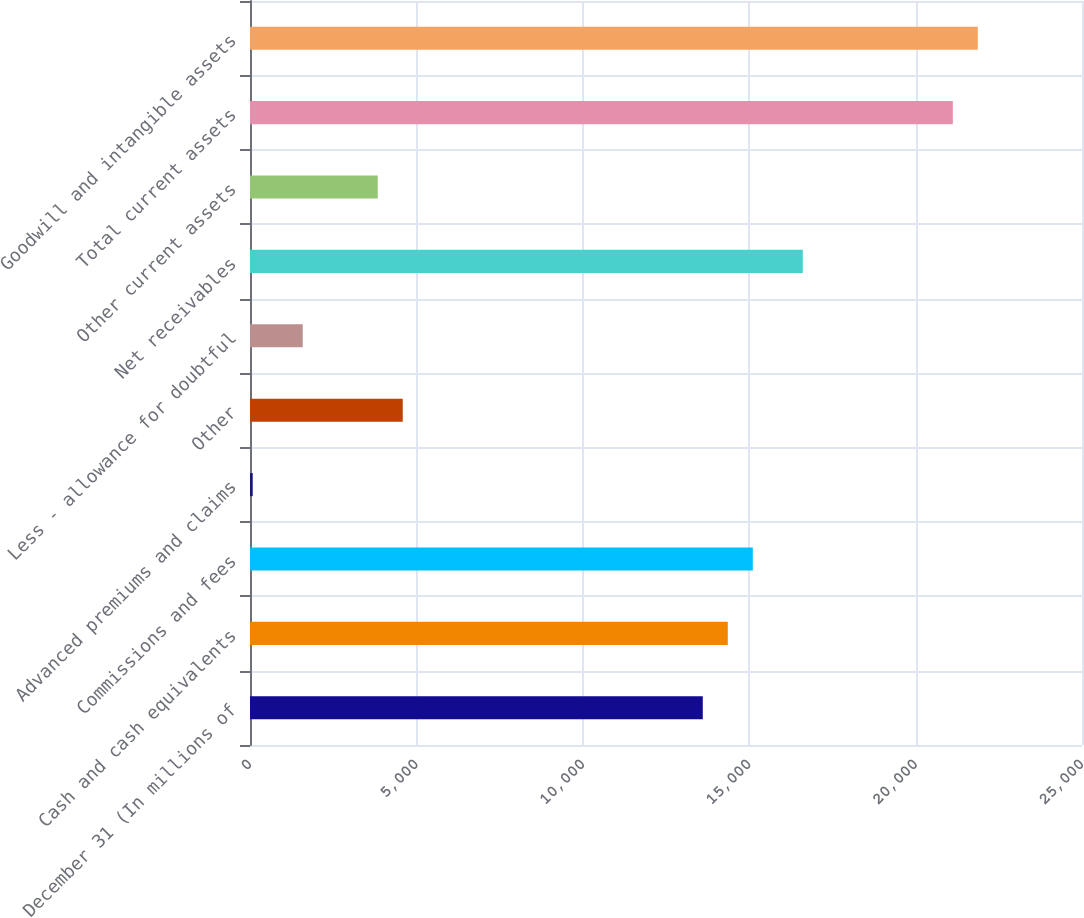Convert chart. <chart><loc_0><loc_0><loc_500><loc_500><bar_chart><fcel>December 31 (In millions of<fcel>Cash and cash equivalents<fcel>Commissions and fees<fcel>Advanced premiums and claims<fcel>Other<fcel>Less - allowance for doubtful<fcel>Net receivables<fcel>Other current assets<fcel>Total current assets<fcel>Goodwill and intangible assets<nl><fcel>13605.4<fcel>14356.7<fcel>15108<fcel>82<fcel>4589.8<fcel>1584.6<fcel>16610.6<fcel>3838.5<fcel>21118.4<fcel>21869.7<nl></chart> 